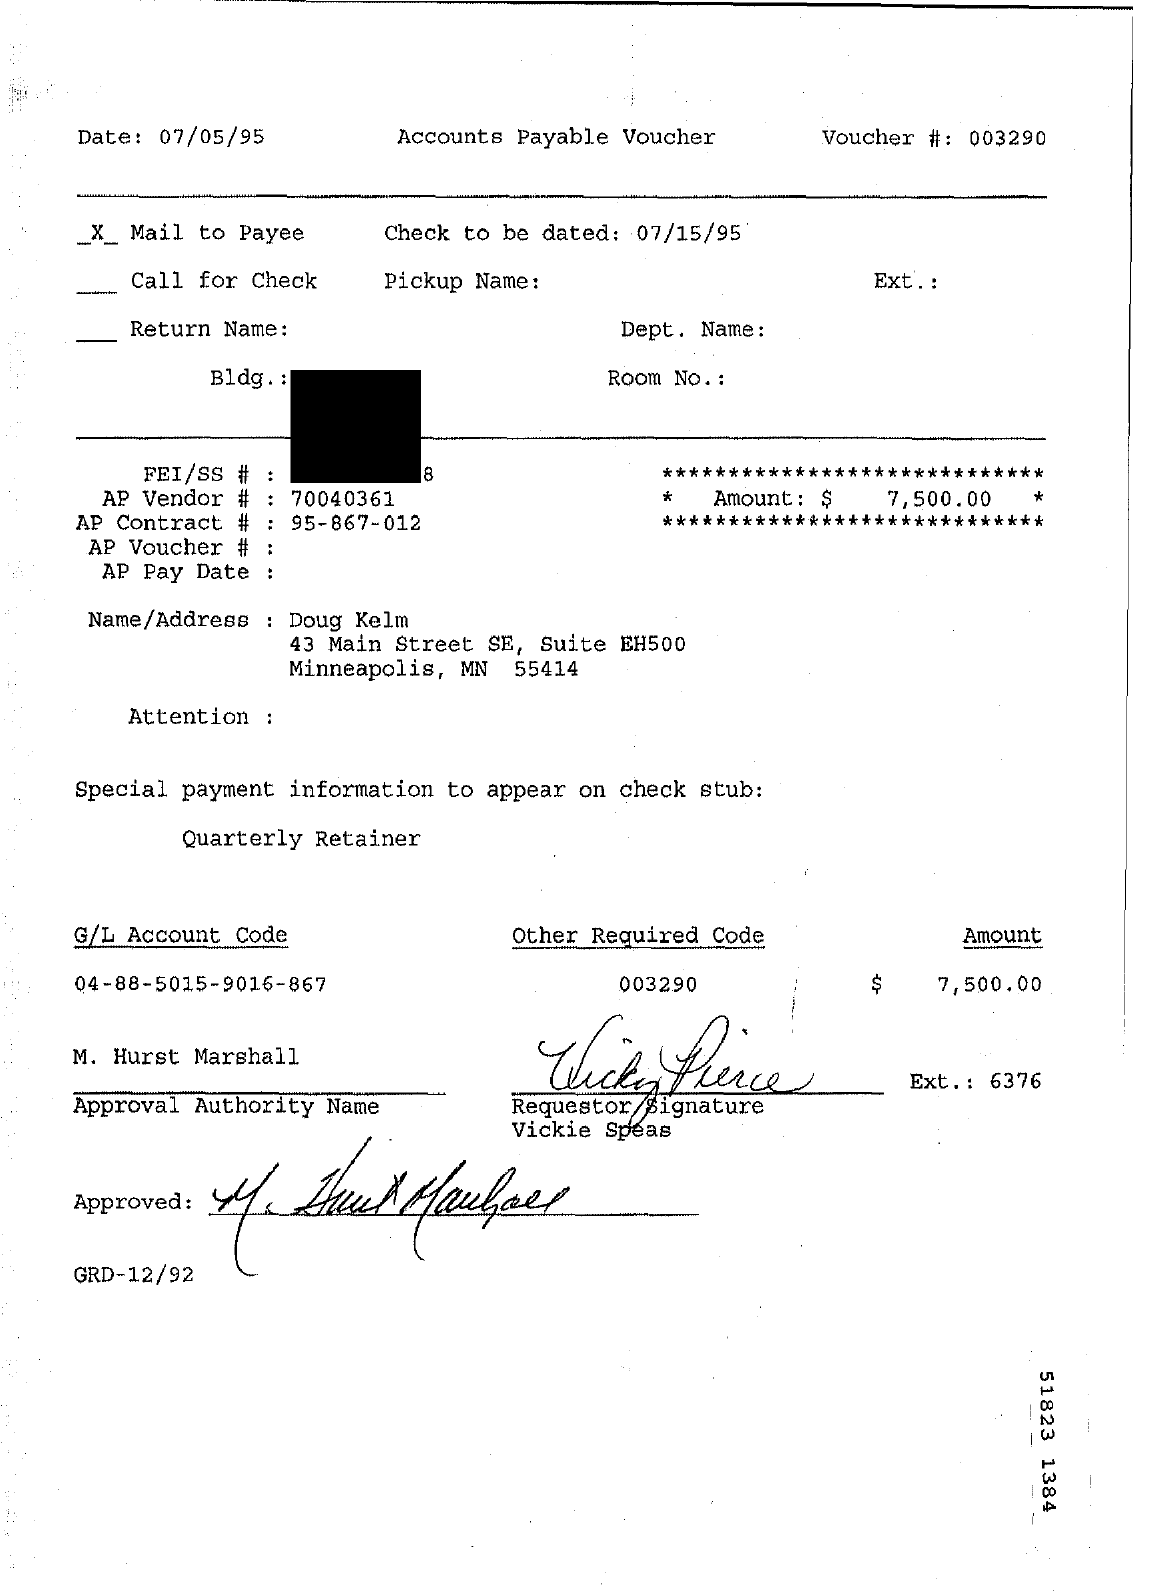What is the voucher number?
Your answer should be very brief. 003290. When is the document dated?
Your answer should be very brief. 07/05/95. What type of documentation is this?
Provide a succinct answer. Accounts Payable Voucher. What is the AP vendor number?
Your response must be concise. 70040361. What is the AP Contract #?
Ensure brevity in your answer.  95-867-012. When is the check to be dated?
Ensure brevity in your answer.  07/15/95. Who is the approval authority?
Offer a very short reply. M. Hurst Marshall. 